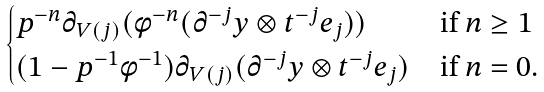Convert formula to latex. <formula><loc_0><loc_0><loc_500><loc_500>\begin{cases} p ^ { - n } \partial _ { V ( j ) } ( \phi ^ { - n } ( \partial ^ { - j } y \otimes t ^ { - j } e _ { j } ) ) & \text {if $n \geq 1$} \\ ( 1 - p ^ { - 1 } \phi ^ { - 1 } ) \partial _ { V ( j ) } ( \partial ^ { - j } y \otimes t ^ { - j } e _ { j } ) & \text {if $n = 0$.} \end{cases}</formula> 